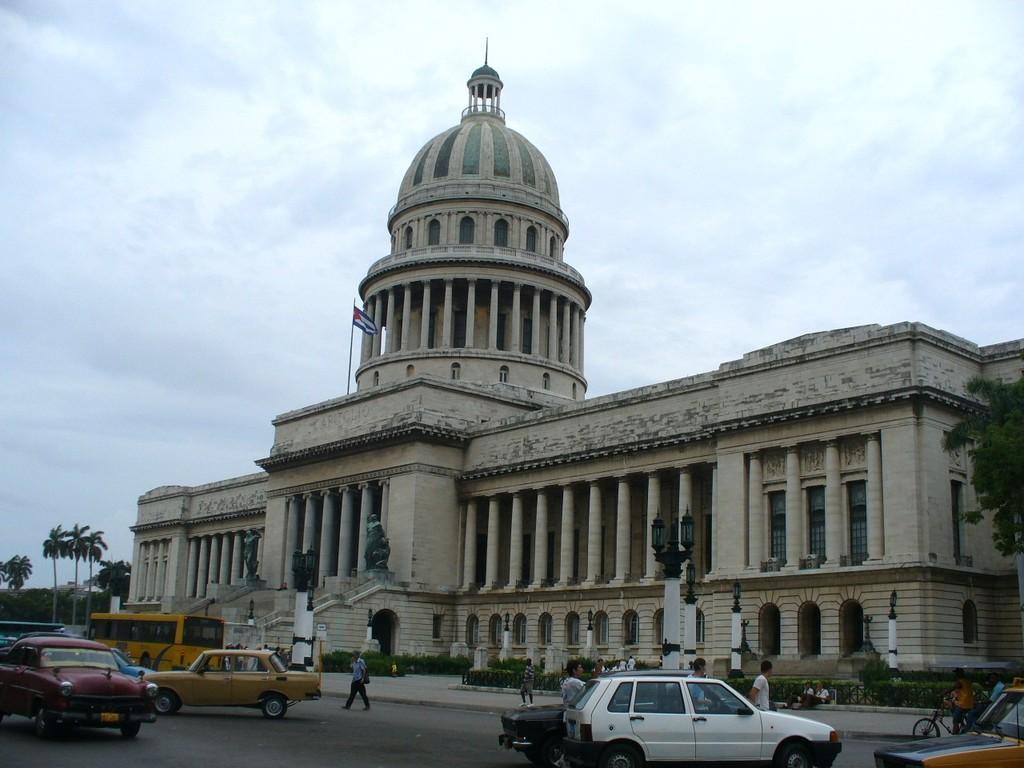Describe this image in one or two sentences. In this image in the front there are vehicles moving on the road and there are persons walking and there are light poles. In the background there is castle and there are trees and the sky is cloudy. 